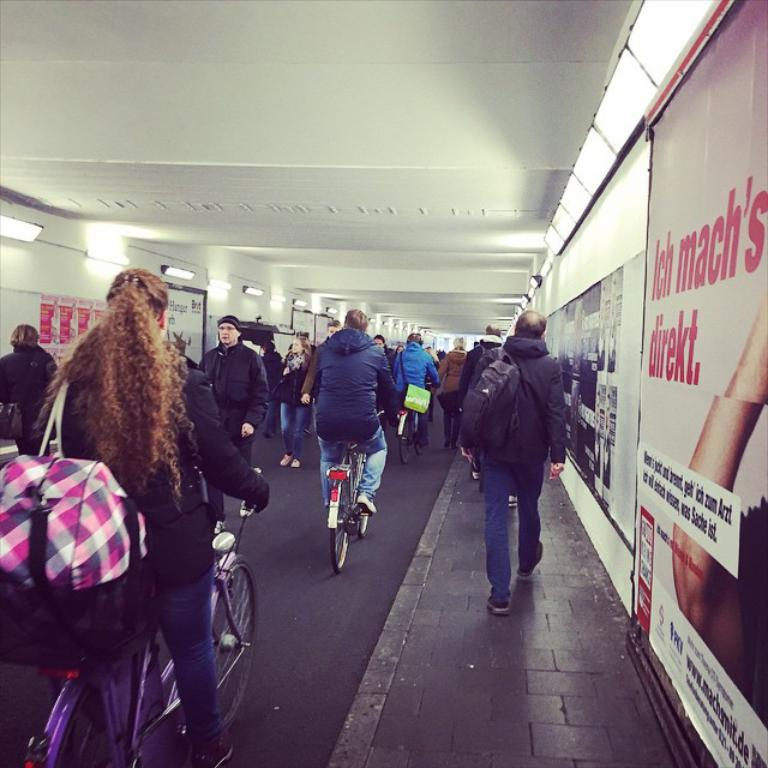What type of decorations are present in the image? There are banners in the image. What other subjects can be seen in the image? There are people and bicycles in the image. What type of whip can be seen being used by the people in the image? There is no whip present in the image; it only features banners, people, and bicycles. What type of yard is visible in the image? There is no yard present in the image. 